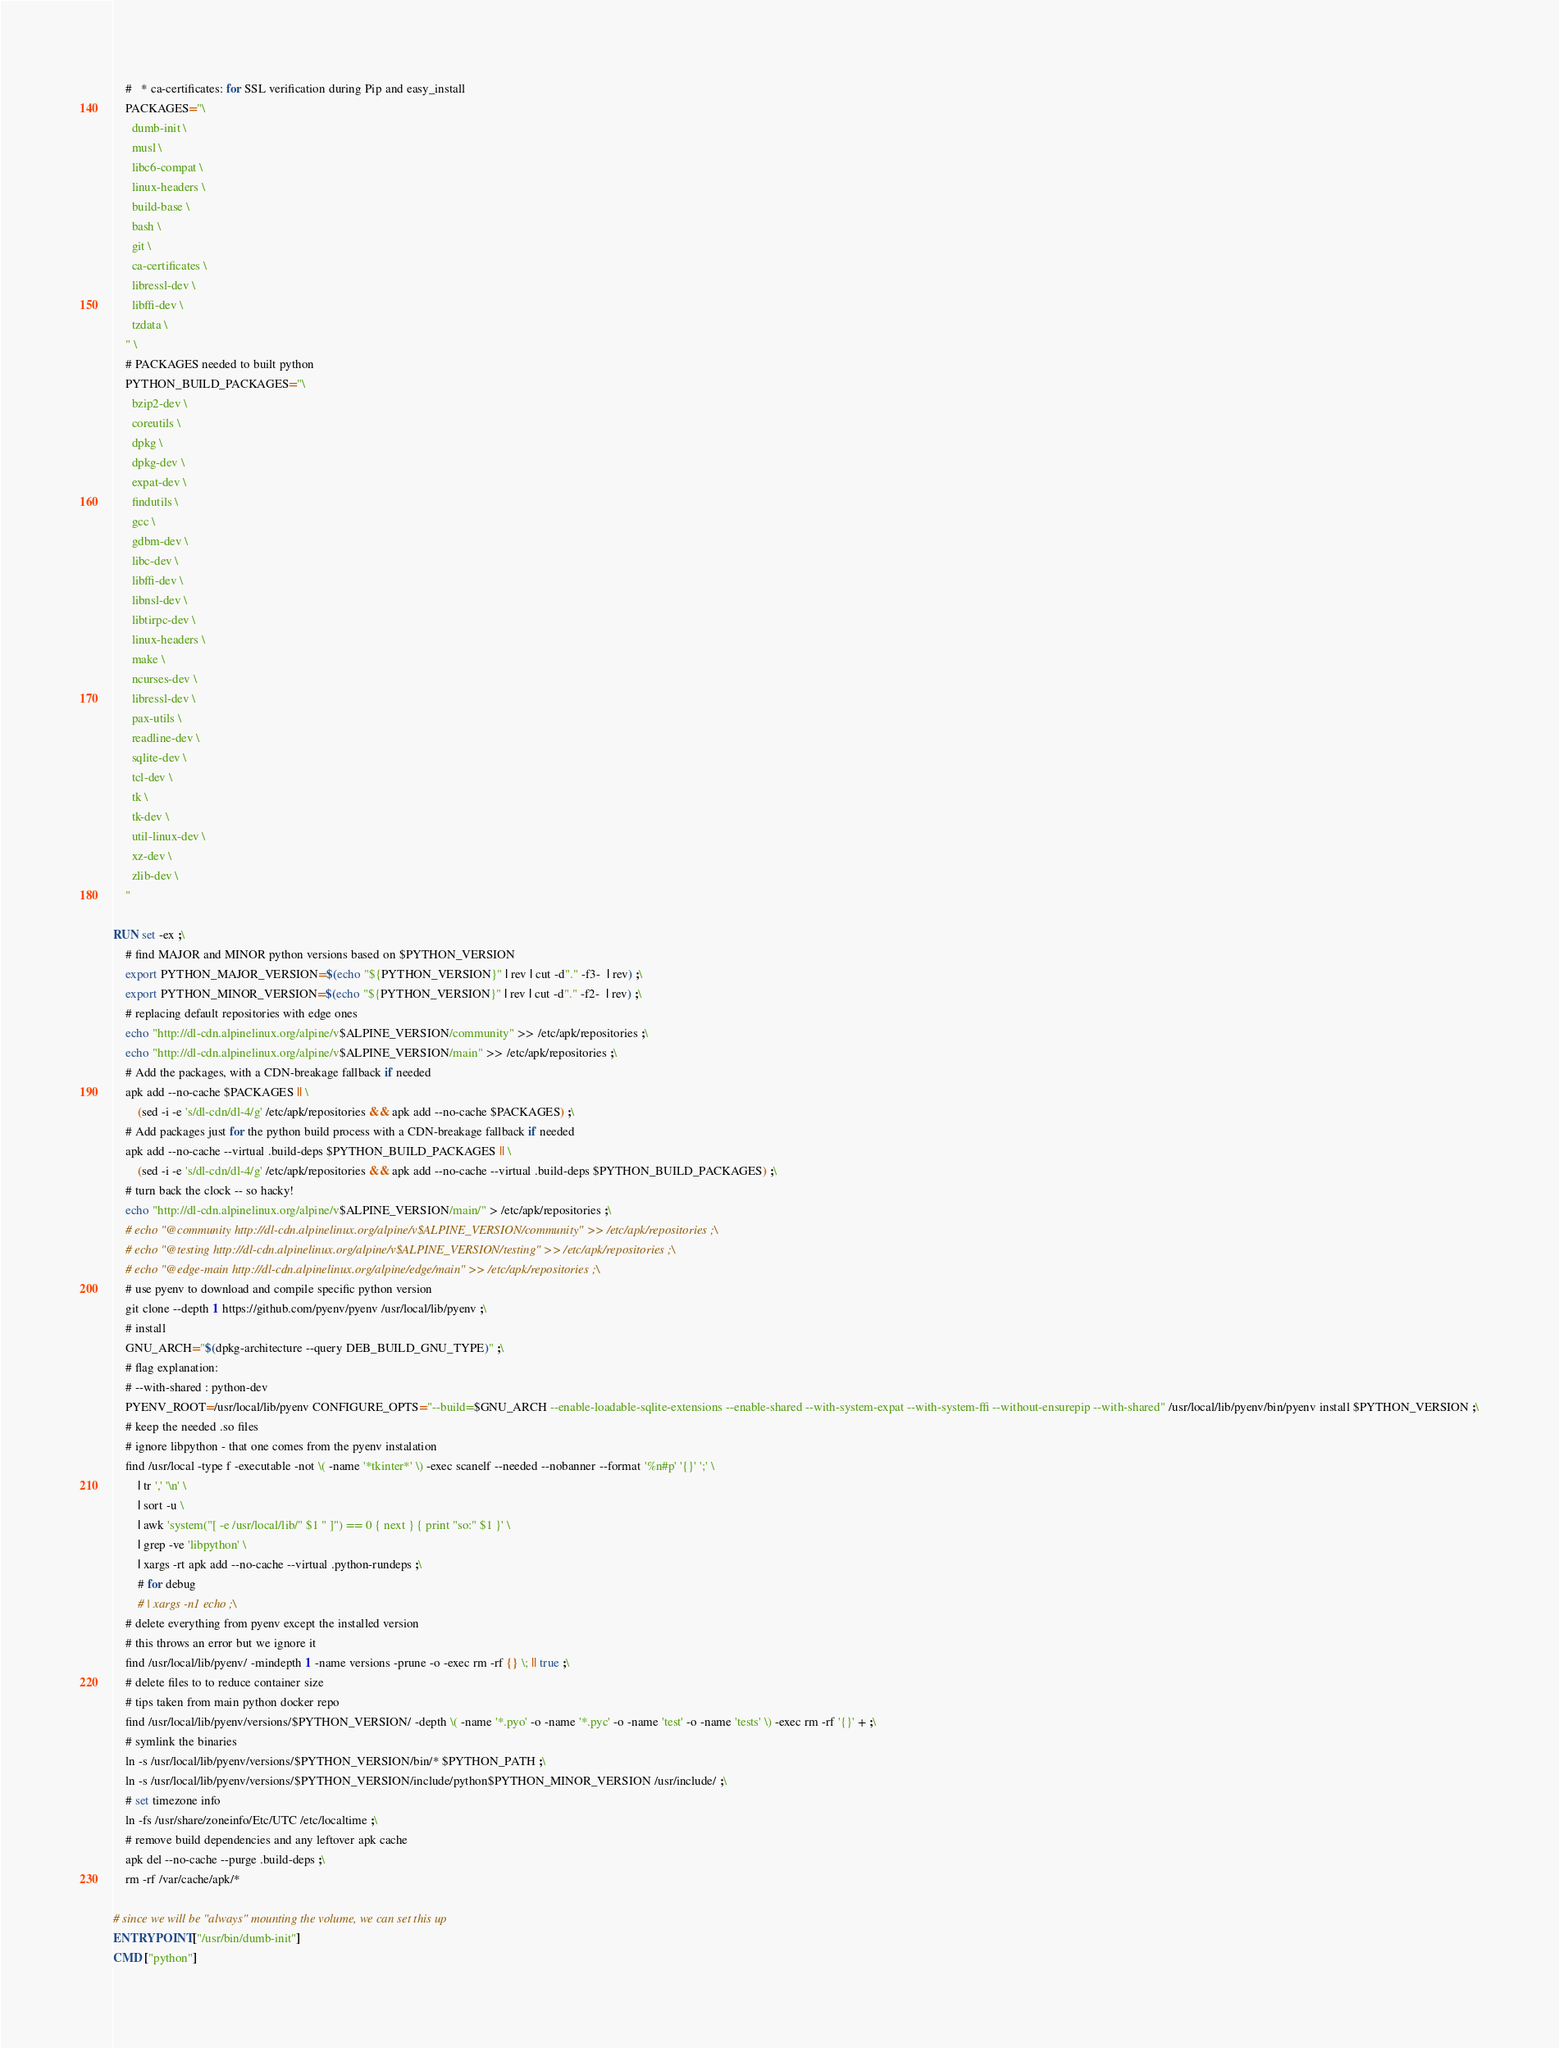<code> <loc_0><loc_0><loc_500><loc_500><_Dockerfile_>    #   * ca-certificates: for SSL verification during Pip and easy_install
    PACKAGES="\
      dumb-init \
      musl \
      libc6-compat \
      linux-headers \
      build-base \
      bash \
      git \
      ca-certificates \
      libressl-dev \
      libffi-dev \
      tzdata \
    " \
    # PACKAGES needed to built python
    PYTHON_BUILD_PACKAGES="\
      bzip2-dev \
      coreutils \
      dpkg \
      dpkg-dev \
      expat-dev \
      findutils \
      gcc \
      gdbm-dev \
      libc-dev \
      libffi-dev \
      libnsl-dev \
      libtirpc-dev \
      linux-headers \
      make \
      ncurses-dev \
      libressl-dev \
      pax-utils \
      readline-dev \
      sqlite-dev \
      tcl-dev \
      tk \
      tk-dev \
      util-linux-dev \
      xz-dev \
      zlib-dev \
    "

RUN set -ex ;\
    # find MAJOR and MINOR python versions based on $PYTHON_VERSION
    export PYTHON_MAJOR_VERSION=$(echo "${PYTHON_VERSION}" | rev | cut -d"." -f3-  | rev) ;\
    export PYTHON_MINOR_VERSION=$(echo "${PYTHON_VERSION}" | rev | cut -d"." -f2-  | rev) ;\
    # replacing default repositories with edge ones
    echo "http://dl-cdn.alpinelinux.org/alpine/v$ALPINE_VERSION/community" >> /etc/apk/repositories ;\
    echo "http://dl-cdn.alpinelinux.org/alpine/v$ALPINE_VERSION/main" >> /etc/apk/repositories ;\
    # Add the packages, with a CDN-breakage fallback if needed
    apk add --no-cache $PACKAGES || \
        (sed -i -e 's/dl-cdn/dl-4/g' /etc/apk/repositories && apk add --no-cache $PACKAGES) ;\
    # Add packages just for the python build process with a CDN-breakage fallback if needed
    apk add --no-cache --virtual .build-deps $PYTHON_BUILD_PACKAGES || \
        (sed -i -e 's/dl-cdn/dl-4/g' /etc/apk/repositories && apk add --no-cache --virtual .build-deps $PYTHON_BUILD_PACKAGES) ;\
    # turn back the clock -- so hacky!
    echo "http://dl-cdn.alpinelinux.org/alpine/v$ALPINE_VERSION/main/" > /etc/apk/repositories ;\
    # echo "@community http://dl-cdn.alpinelinux.org/alpine/v$ALPINE_VERSION/community" >> /etc/apk/repositories ;\
    # echo "@testing http://dl-cdn.alpinelinux.org/alpine/v$ALPINE_VERSION/testing" >> /etc/apk/repositories ;\
    # echo "@edge-main http://dl-cdn.alpinelinux.org/alpine/edge/main" >> /etc/apk/repositories ;\
    # use pyenv to download and compile specific python version
    git clone --depth 1 https://github.com/pyenv/pyenv /usr/local/lib/pyenv ;\
    # install
    GNU_ARCH="$(dpkg-architecture --query DEB_BUILD_GNU_TYPE)" ;\
    # flag explanation:
    # --with-shared : python-dev
    PYENV_ROOT=/usr/local/lib/pyenv CONFIGURE_OPTS="--build=$GNU_ARCH --enable-loadable-sqlite-extensions --enable-shared --with-system-expat --with-system-ffi --without-ensurepip --with-shared" /usr/local/lib/pyenv/bin/pyenv install $PYTHON_VERSION ;\
    # keep the needed .so files
    # ignore libpython - that one comes from the pyenv instalation
    find /usr/local -type f -executable -not \( -name '*tkinter*' \) -exec scanelf --needed --nobanner --format '%n#p' '{}' ';' \
        | tr ',' '\n' \
        | sort -u \
        | awk 'system("[ -e /usr/local/lib/" $1 " ]") == 0 { next } { print "so:" $1 }' \
        | grep -ve 'libpython' \
        | xargs -rt apk add --no-cache --virtual .python-rundeps ;\
        # for debug
        # | xargs -n1 echo ;\
    # delete everything from pyenv except the installed version
    # this throws an error but we ignore it
    find /usr/local/lib/pyenv/ -mindepth 1 -name versions -prune -o -exec rm -rf {} \; || true ;\
    # delete files to to reduce container size
    # tips taken from main python docker repo
    find /usr/local/lib/pyenv/versions/$PYTHON_VERSION/ -depth \( -name '*.pyo' -o -name '*.pyc' -o -name 'test' -o -name 'tests' \) -exec rm -rf '{}' + ;\
    # symlink the binaries
    ln -s /usr/local/lib/pyenv/versions/$PYTHON_VERSION/bin/* $PYTHON_PATH ;\
    ln -s /usr/local/lib/pyenv/versions/$PYTHON_VERSION/include/python$PYTHON_MINOR_VERSION /usr/include/ ;\
    # set timezone info
    ln -fs /usr/share/zoneinfo/Etc/UTC /etc/localtime ;\
    # remove build dependencies and any leftover apk cache
    apk del --no-cache --purge .build-deps ;\
    rm -rf /var/cache/apk/*

# since we will be "always" mounting the volume, we can set this up
ENTRYPOINT ["/usr/bin/dumb-init"]
CMD ["python"]
</code> 